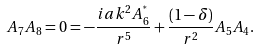<formula> <loc_0><loc_0><loc_500><loc_500>A _ { 7 } A _ { 8 } = 0 = - \frac { i a k ^ { 2 } A _ { 6 } ^ { ^ { * } } } { r ^ { 5 } } + \frac { ( 1 - \delta ) } { r ^ { 2 } } A _ { 5 } A _ { 4 } .</formula> 